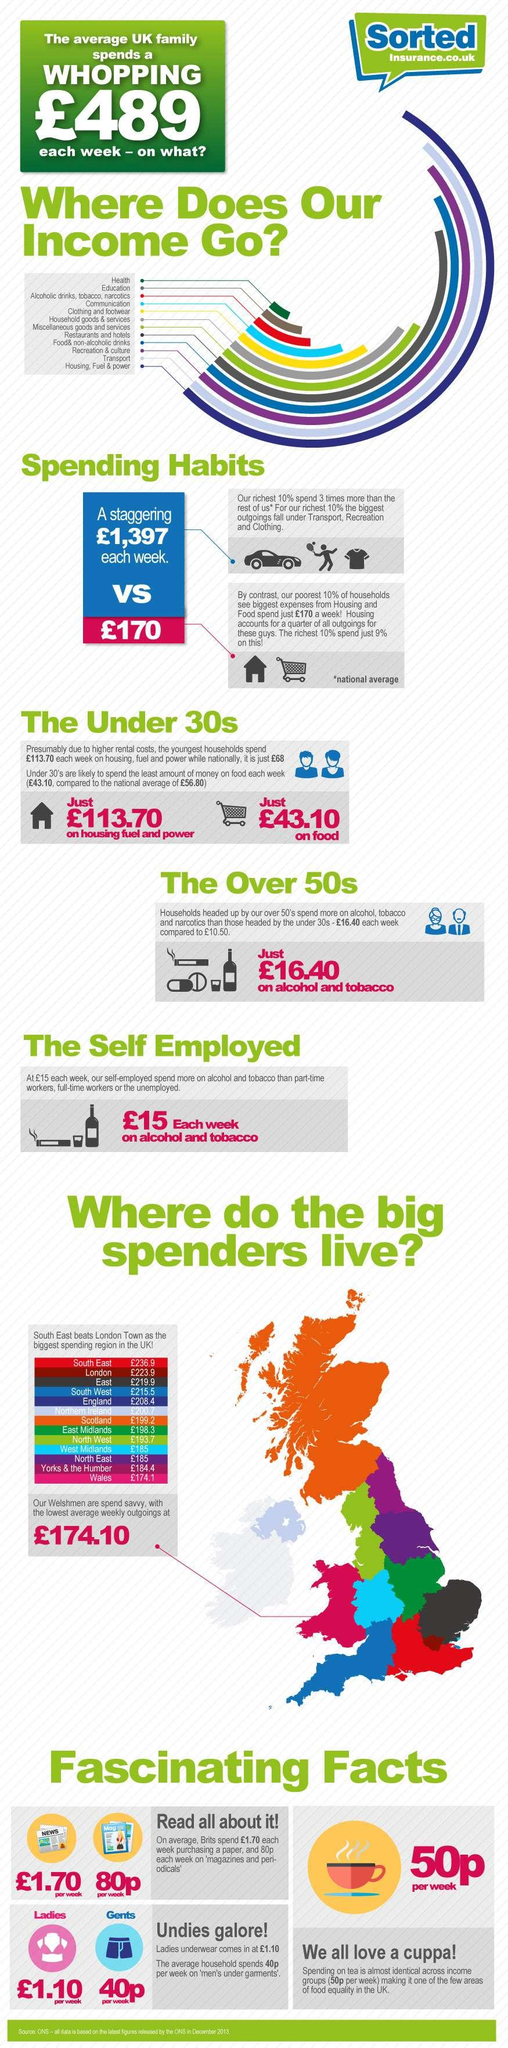List a handful of essential elements in this visual. On an average week, a typical UK family spends the second least amount on education, with the exception of housing, which is their highest expenditure. The cost of housing, fuel, and power for the youngest households is significantly higher than the national average, amounting to £45.70. The national average expenditure for housing, fuel, and power in the United Kingdom is approximately £68 per month. The poorest 10% of individuals allocate a significant portion of their weekly expenses towards housing and food. The richest 10% spend the most of their weekly budget on transportation, recreation, and clothing. 